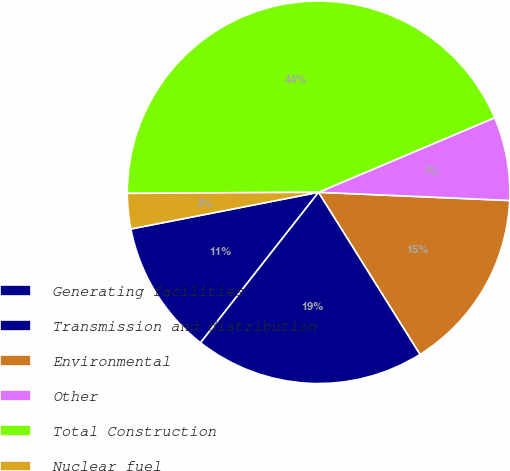Convert chart. <chart><loc_0><loc_0><loc_500><loc_500><pie_chart><fcel>Generating facilities<fcel>Transmission and distribution<fcel>Environmental<fcel>Other<fcel>Total Construction<fcel>Nuclear fuel<nl><fcel>11.34%<fcel>19.49%<fcel>15.41%<fcel>7.06%<fcel>43.72%<fcel>2.98%<nl></chart> 